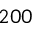Convert formula to latex. <formula><loc_0><loc_0><loc_500><loc_500>2 0 0</formula> 